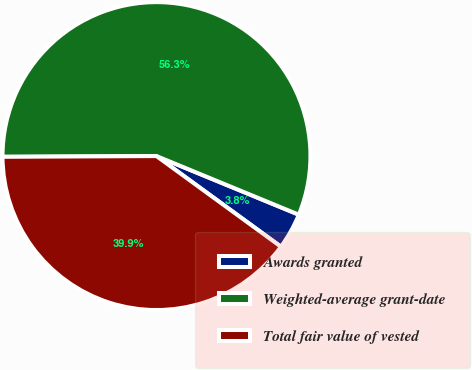Convert chart. <chart><loc_0><loc_0><loc_500><loc_500><pie_chart><fcel>Awards granted<fcel>Weighted-average grant-date<fcel>Total fair value of vested<nl><fcel>3.8%<fcel>56.29%<fcel>39.91%<nl></chart> 